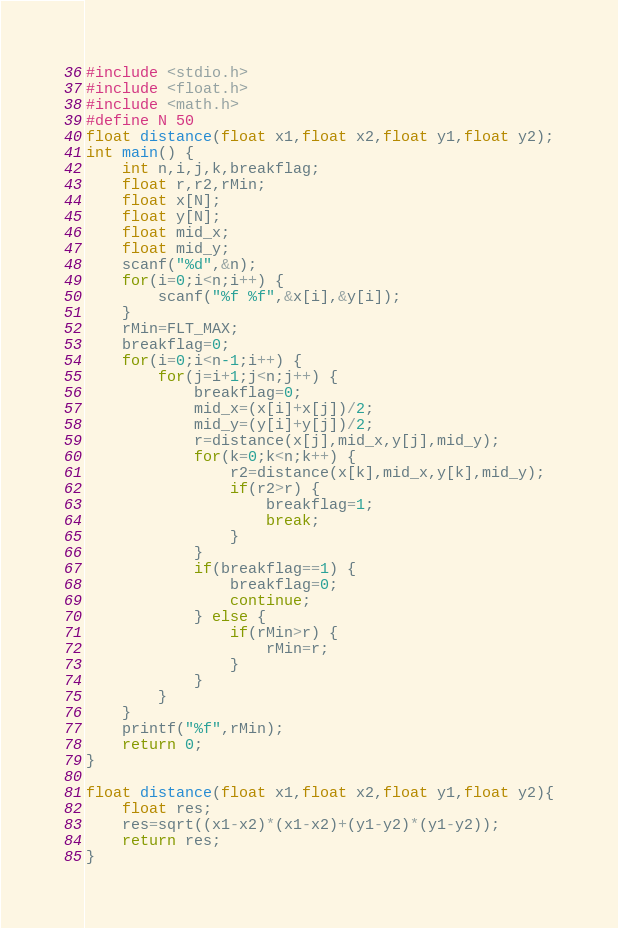Convert code to text. <code><loc_0><loc_0><loc_500><loc_500><_C_>#include <stdio.h>
#include <float.h>
#include <math.h>
#define N 50
float distance(float x1,float x2,float y1,float y2);
int main() {
	int n,i,j,k,breakflag;
	float r,r2,rMin;
	float x[N];
	float y[N];
	float mid_x;
	float mid_y;
	scanf("%d",&n);
	for(i=0;i<n;i++) {
		scanf("%f %f",&x[i],&y[i]);
	}
	rMin=FLT_MAX;
	breakflag=0;
	for(i=0;i<n-1;i++) {
		for(j=i+1;j<n;j++) {
			breakflag=0;
			mid_x=(x[i]+x[j])/2;
			mid_y=(y[i]+y[j])/2;
			r=distance(x[j],mid_x,y[j],mid_y);
			for(k=0;k<n;k++) {
				r2=distance(x[k],mid_x,y[k],mid_y);
				if(r2>r) {
					breakflag=1;
					break;
				}
			}
			if(breakflag==1) {
				breakflag=0;
				continue;
			} else {
				if(rMin>r) {
					rMin=r;
				}
			}
		}
	}
	printf("%f",rMin);
	return 0;
}

float distance(float x1,float x2,float y1,float y2){
	float res;
	res=sqrt((x1-x2)*(x1-x2)+(y1-y2)*(y1-y2));
	return res;
}	</code> 